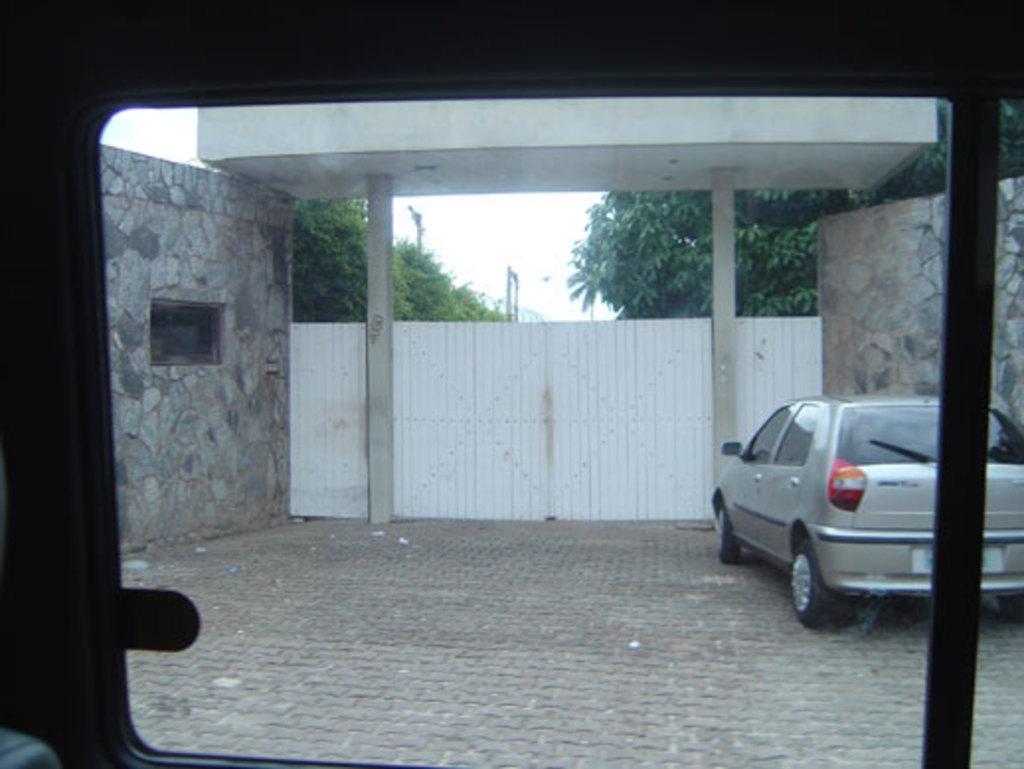How would you summarize this image in a sentence or two? In this image we can see a motor vehicle on the floor, gate, trees, walls and sky. 